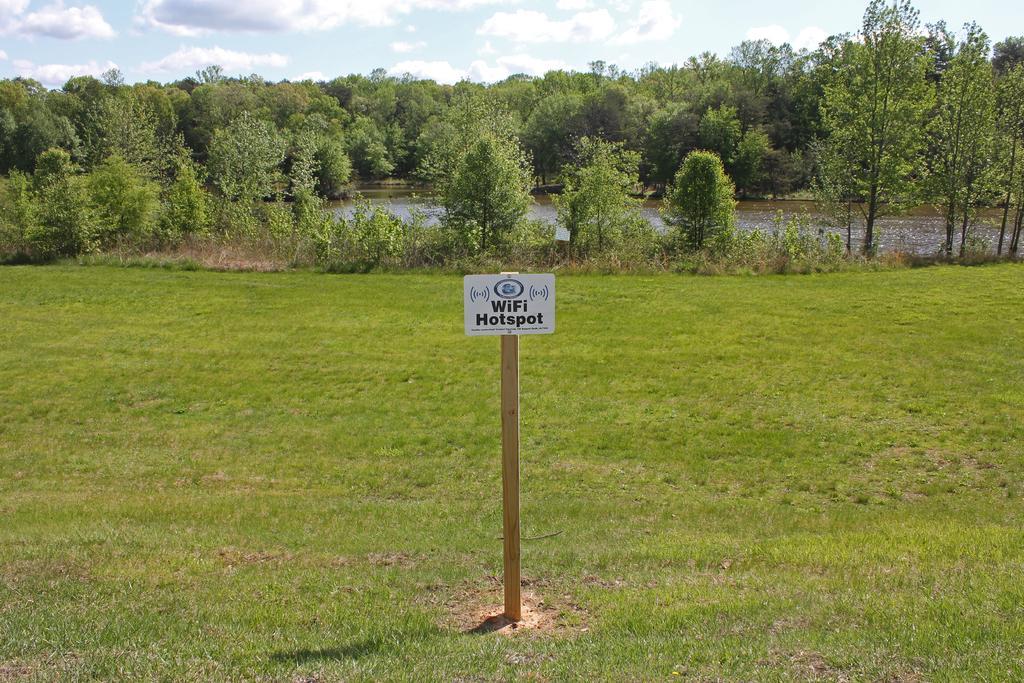Could you give a brief overview of what you see in this image? In this image I can see the white color board to the wall. To the board I can see the name WiFi hot-spot is written. In the back there are many trees and the water. I can also see the clouds and the sky. 